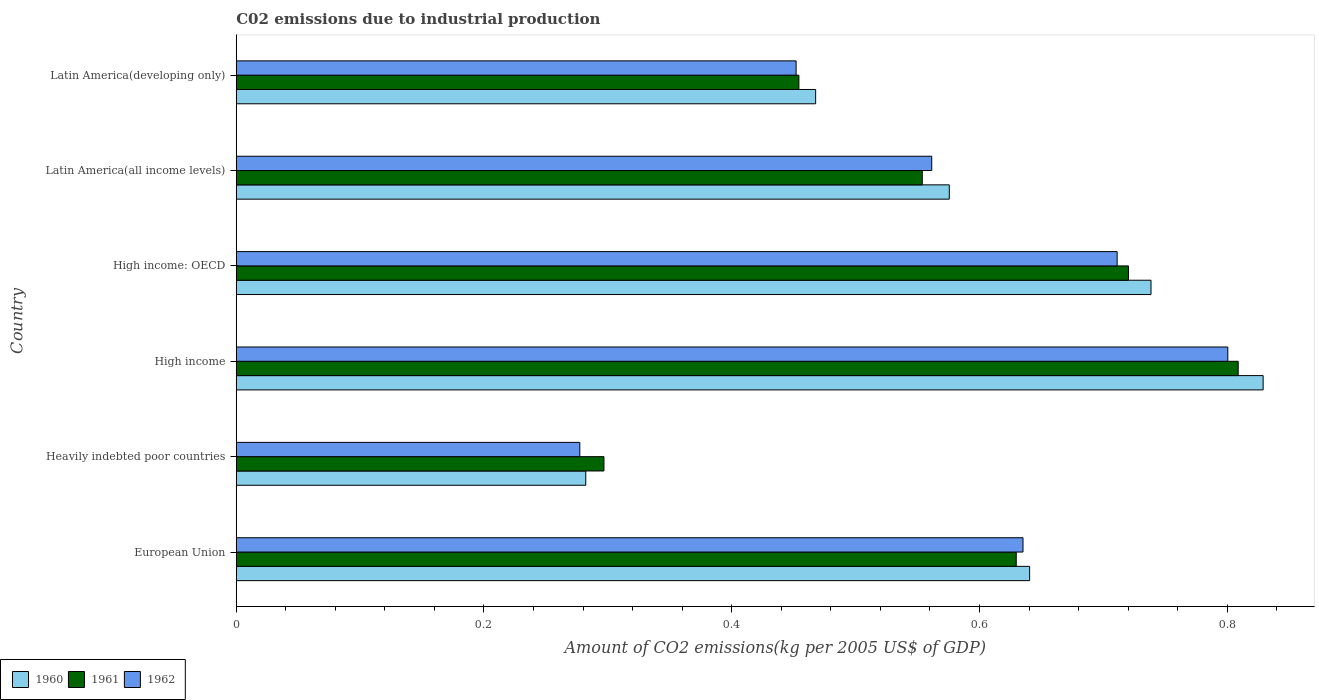How many different coloured bars are there?
Your answer should be very brief. 3. How many groups of bars are there?
Give a very brief answer. 6. Are the number of bars on each tick of the Y-axis equal?
Offer a terse response. Yes. How many bars are there on the 1st tick from the top?
Your answer should be compact. 3. How many bars are there on the 5th tick from the bottom?
Give a very brief answer. 3. What is the amount of CO2 emitted due to industrial production in 1960 in High income: OECD?
Make the answer very short. 0.74. Across all countries, what is the maximum amount of CO2 emitted due to industrial production in 1962?
Give a very brief answer. 0.8. Across all countries, what is the minimum amount of CO2 emitted due to industrial production in 1961?
Make the answer very short. 0.3. In which country was the amount of CO2 emitted due to industrial production in 1960 maximum?
Offer a terse response. High income. In which country was the amount of CO2 emitted due to industrial production in 1962 minimum?
Make the answer very short. Heavily indebted poor countries. What is the total amount of CO2 emitted due to industrial production in 1960 in the graph?
Your response must be concise. 3.53. What is the difference between the amount of CO2 emitted due to industrial production in 1961 in European Union and that in Latin America(developing only)?
Offer a terse response. 0.18. What is the difference between the amount of CO2 emitted due to industrial production in 1960 in Heavily indebted poor countries and the amount of CO2 emitted due to industrial production in 1961 in Latin America(developing only)?
Ensure brevity in your answer.  -0.17. What is the average amount of CO2 emitted due to industrial production in 1962 per country?
Your response must be concise. 0.57. What is the difference between the amount of CO2 emitted due to industrial production in 1960 and amount of CO2 emitted due to industrial production in 1961 in Latin America(all income levels)?
Provide a succinct answer. 0.02. In how many countries, is the amount of CO2 emitted due to industrial production in 1960 greater than 0.7200000000000001 kg?
Ensure brevity in your answer.  2. What is the ratio of the amount of CO2 emitted due to industrial production in 1961 in Latin America(all income levels) to that in Latin America(developing only)?
Ensure brevity in your answer.  1.22. Is the amount of CO2 emitted due to industrial production in 1962 in European Union less than that in Latin America(developing only)?
Keep it short and to the point. No. What is the difference between the highest and the second highest amount of CO2 emitted due to industrial production in 1961?
Give a very brief answer. 0.09. What is the difference between the highest and the lowest amount of CO2 emitted due to industrial production in 1961?
Offer a terse response. 0.51. Is the sum of the amount of CO2 emitted due to industrial production in 1961 in European Union and Heavily indebted poor countries greater than the maximum amount of CO2 emitted due to industrial production in 1960 across all countries?
Ensure brevity in your answer.  Yes. Is it the case that in every country, the sum of the amount of CO2 emitted due to industrial production in 1962 and amount of CO2 emitted due to industrial production in 1960 is greater than the amount of CO2 emitted due to industrial production in 1961?
Give a very brief answer. Yes. Are all the bars in the graph horizontal?
Ensure brevity in your answer.  Yes. How many countries are there in the graph?
Offer a terse response. 6. Are the values on the major ticks of X-axis written in scientific E-notation?
Your answer should be compact. No. Does the graph contain any zero values?
Provide a succinct answer. No. Does the graph contain grids?
Ensure brevity in your answer.  No. How many legend labels are there?
Offer a terse response. 3. How are the legend labels stacked?
Provide a short and direct response. Horizontal. What is the title of the graph?
Your answer should be very brief. C02 emissions due to industrial production. What is the label or title of the X-axis?
Provide a short and direct response. Amount of CO2 emissions(kg per 2005 US$ of GDP). What is the label or title of the Y-axis?
Make the answer very short. Country. What is the Amount of CO2 emissions(kg per 2005 US$ of GDP) in 1960 in European Union?
Provide a short and direct response. 0.64. What is the Amount of CO2 emissions(kg per 2005 US$ of GDP) in 1961 in European Union?
Give a very brief answer. 0.63. What is the Amount of CO2 emissions(kg per 2005 US$ of GDP) of 1962 in European Union?
Keep it short and to the point. 0.64. What is the Amount of CO2 emissions(kg per 2005 US$ of GDP) of 1960 in Heavily indebted poor countries?
Your response must be concise. 0.28. What is the Amount of CO2 emissions(kg per 2005 US$ of GDP) in 1961 in Heavily indebted poor countries?
Your answer should be compact. 0.3. What is the Amount of CO2 emissions(kg per 2005 US$ of GDP) of 1962 in Heavily indebted poor countries?
Offer a terse response. 0.28. What is the Amount of CO2 emissions(kg per 2005 US$ of GDP) of 1960 in High income?
Give a very brief answer. 0.83. What is the Amount of CO2 emissions(kg per 2005 US$ of GDP) of 1961 in High income?
Provide a short and direct response. 0.81. What is the Amount of CO2 emissions(kg per 2005 US$ of GDP) of 1962 in High income?
Ensure brevity in your answer.  0.8. What is the Amount of CO2 emissions(kg per 2005 US$ of GDP) of 1960 in High income: OECD?
Your answer should be very brief. 0.74. What is the Amount of CO2 emissions(kg per 2005 US$ of GDP) of 1961 in High income: OECD?
Offer a very short reply. 0.72. What is the Amount of CO2 emissions(kg per 2005 US$ of GDP) of 1962 in High income: OECD?
Make the answer very short. 0.71. What is the Amount of CO2 emissions(kg per 2005 US$ of GDP) in 1960 in Latin America(all income levels)?
Your answer should be compact. 0.58. What is the Amount of CO2 emissions(kg per 2005 US$ of GDP) in 1961 in Latin America(all income levels)?
Give a very brief answer. 0.55. What is the Amount of CO2 emissions(kg per 2005 US$ of GDP) in 1962 in Latin America(all income levels)?
Your answer should be compact. 0.56. What is the Amount of CO2 emissions(kg per 2005 US$ of GDP) of 1960 in Latin America(developing only)?
Ensure brevity in your answer.  0.47. What is the Amount of CO2 emissions(kg per 2005 US$ of GDP) in 1961 in Latin America(developing only)?
Ensure brevity in your answer.  0.45. What is the Amount of CO2 emissions(kg per 2005 US$ of GDP) in 1962 in Latin America(developing only)?
Give a very brief answer. 0.45. Across all countries, what is the maximum Amount of CO2 emissions(kg per 2005 US$ of GDP) of 1960?
Provide a succinct answer. 0.83. Across all countries, what is the maximum Amount of CO2 emissions(kg per 2005 US$ of GDP) of 1961?
Give a very brief answer. 0.81. Across all countries, what is the maximum Amount of CO2 emissions(kg per 2005 US$ of GDP) in 1962?
Give a very brief answer. 0.8. Across all countries, what is the minimum Amount of CO2 emissions(kg per 2005 US$ of GDP) of 1960?
Keep it short and to the point. 0.28. Across all countries, what is the minimum Amount of CO2 emissions(kg per 2005 US$ of GDP) in 1961?
Your answer should be compact. 0.3. Across all countries, what is the minimum Amount of CO2 emissions(kg per 2005 US$ of GDP) of 1962?
Offer a terse response. 0.28. What is the total Amount of CO2 emissions(kg per 2005 US$ of GDP) of 1960 in the graph?
Ensure brevity in your answer.  3.53. What is the total Amount of CO2 emissions(kg per 2005 US$ of GDP) of 1961 in the graph?
Offer a very short reply. 3.46. What is the total Amount of CO2 emissions(kg per 2005 US$ of GDP) of 1962 in the graph?
Ensure brevity in your answer.  3.44. What is the difference between the Amount of CO2 emissions(kg per 2005 US$ of GDP) of 1960 in European Union and that in Heavily indebted poor countries?
Offer a terse response. 0.36. What is the difference between the Amount of CO2 emissions(kg per 2005 US$ of GDP) of 1961 in European Union and that in Heavily indebted poor countries?
Your response must be concise. 0.33. What is the difference between the Amount of CO2 emissions(kg per 2005 US$ of GDP) of 1962 in European Union and that in Heavily indebted poor countries?
Provide a succinct answer. 0.36. What is the difference between the Amount of CO2 emissions(kg per 2005 US$ of GDP) in 1960 in European Union and that in High income?
Offer a very short reply. -0.19. What is the difference between the Amount of CO2 emissions(kg per 2005 US$ of GDP) of 1961 in European Union and that in High income?
Your answer should be compact. -0.18. What is the difference between the Amount of CO2 emissions(kg per 2005 US$ of GDP) in 1962 in European Union and that in High income?
Make the answer very short. -0.17. What is the difference between the Amount of CO2 emissions(kg per 2005 US$ of GDP) of 1960 in European Union and that in High income: OECD?
Your answer should be compact. -0.1. What is the difference between the Amount of CO2 emissions(kg per 2005 US$ of GDP) in 1961 in European Union and that in High income: OECD?
Keep it short and to the point. -0.09. What is the difference between the Amount of CO2 emissions(kg per 2005 US$ of GDP) of 1962 in European Union and that in High income: OECD?
Provide a short and direct response. -0.08. What is the difference between the Amount of CO2 emissions(kg per 2005 US$ of GDP) in 1960 in European Union and that in Latin America(all income levels)?
Provide a short and direct response. 0.06. What is the difference between the Amount of CO2 emissions(kg per 2005 US$ of GDP) of 1961 in European Union and that in Latin America(all income levels)?
Offer a terse response. 0.08. What is the difference between the Amount of CO2 emissions(kg per 2005 US$ of GDP) in 1962 in European Union and that in Latin America(all income levels)?
Offer a terse response. 0.07. What is the difference between the Amount of CO2 emissions(kg per 2005 US$ of GDP) in 1960 in European Union and that in Latin America(developing only)?
Keep it short and to the point. 0.17. What is the difference between the Amount of CO2 emissions(kg per 2005 US$ of GDP) of 1961 in European Union and that in Latin America(developing only)?
Ensure brevity in your answer.  0.18. What is the difference between the Amount of CO2 emissions(kg per 2005 US$ of GDP) in 1962 in European Union and that in Latin America(developing only)?
Your answer should be very brief. 0.18. What is the difference between the Amount of CO2 emissions(kg per 2005 US$ of GDP) of 1960 in Heavily indebted poor countries and that in High income?
Your answer should be very brief. -0.55. What is the difference between the Amount of CO2 emissions(kg per 2005 US$ of GDP) in 1961 in Heavily indebted poor countries and that in High income?
Give a very brief answer. -0.51. What is the difference between the Amount of CO2 emissions(kg per 2005 US$ of GDP) in 1962 in Heavily indebted poor countries and that in High income?
Offer a very short reply. -0.52. What is the difference between the Amount of CO2 emissions(kg per 2005 US$ of GDP) of 1960 in Heavily indebted poor countries and that in High income: OECD?
Offer a terse response. -0.46. What is the difference between the Amount of CO2 emissions(kg per 2005 US$ of GDP) in 1961 in Heavily indebted poor countries and that in High income: OECD?
Make the answer very short. -0.42. What is the difference between the Amount of CO2 emissions(kg per 2005 US$ of GDP) of 1962 in Heavily indebted poor countries and that in High income: OECD?
Your answer should be very brief. -0.43. What is the difference between the Amount of CO2 emissions(kg per 2005 US$ of GDP) in 1960 in Heavily indebted poor countries and that in Latin America(all income levels)?
Make the answer very short. -0.29. What is the difference between the Amount of CO2 emissions(kg per 2005 US$ of GDP) of 1961 in Heavily indebted poor countries and that in Latin America(all income levels)?
Provide a succinct answer. -0.26. What is the difference between the Amount of CO2 emissions(kg per 2005 US$ of GDP) in 1962 in Heavily indebted poor countries and that in Latin America(all income levels)?
Give a very brief answer. -0.28. What is the difference between the Amount of CO2 emissions(kg per 2005 US$ of GDP) in 1960 in Heavily indebted poor countries and that in Latin America(developing only)?
Your response must be concise. -0.19. What is the difference between the Amount of CO2 emissions(kg per 2005 US$ of GDP) in 1961 in Heavily indebted poor countries and that in Latin America(developing only)?
Give a very brief answer. -0.16. What is the difference between the Amount of CO2 emissions(kg per 2005 US$ of GDP) in 1962 in Heavily indebted poor countries and that in Latin America(developing only)?
Ensure brevity in your answer.  -0.17. What is the difference between the Amount of CO2 emissions(kg per 2005 US$ of GDP) in 1960 in High income and that in High income: OECD?
Your answer should be compact. 0.09. What is the difference between the Amount of CO2 emissions(kg per 2005 US$ of GDP) of 1961 in High income and that in High income: OECD?
Offer a very short reply. 0.09. What is the difference between the Amount of CO2 emissions(kg per 2005 US$ of GDP) in 1962 in High income and that in High income: OECD?
Give a very brief answer. 0.09. What is the difference between the Amount of CO2 emissions(kg per 2005 US$ of GDP) of 1960 in High income and that in Latin America(all income levels)?
Provide a succinct answer. 0.25. What is the difference between the Amount of CO2 emissions(kg per 2005 US$ of GDP) in 1961 in High income and that in Latin America(all income levels)?
Provide a short and direct response. 0.26. What is the difference between the Amount of CO2 emissions(kg per 2005 US$ of GDP) of 1962 in High income and that in Latin America(all income levels)?
Offer a very short reply. 0.24. What is the difference between the Amount of CO2 emissions(kg per 2005 US$ of GDP) of 1960 in High income and that in Latin America(developing only)?
Your answer should be compact. 0.36. What is the difference between the Amount of CO2 emissions(kg per 2005 US$ of GDP) of 1961 in High income and that in Latin America(developing only)?
Give a very brief answer. 0.35. What is the difference between the Amount of CO2 emissions(kg per 2005 US$ of GDP) in 1962 in High income and that in Latin America(developing only)?
Offer a terse response. 0.35. What is the difference between the Amount of CO2 emissions(kg per 2005 US$ of GDP) in 1960 in High income: OECD and that in Latin America(all income levels)?
Offer a very short reply. 0.16. What is the difference between the Amount of CO2 emissions(kg per 2005 US$ of GDP) of 1961 in High income: OECD and that in Latin America(all income levels)?
Offer a very short reply. 0.17. What is the difference between the Amount of CO2 emissions(kg per 2005 US$ of GDP) of 1962 in High income: OECD and that in Latin America(all income levels)?
Provide a short and direct response. 0.15. What is the difference between the Amount of CO2 emissions(kg per 2005 US$ of GDP) in 1960 in High income: OECD and that in Latin America(developing only)?
Provide a short and direct response. 0.27. What is the difference between the Amount of CO2 emissions(kg per 2005 US$ of GDP) in 1961 in High income: OECD and that in Latin America(developing only)?
Give a very brief answer. 0.27. What is the difference between the Amount of CO2 emissions(kg per 2005 US$ of GDP) in 1962 in High income: OECD and that in Latin America(developing only)?
Offer a very short reply. 0.26. What is the difference between the Amount of CO2 emissions(kg per 2005 US$ of GDP) in 1960 in Latin America(all income levels) and that in Latin America(developing only)?
Ensure brevity in your answer.  0.11. What is the difference between the Amount of CO2 emissions(kg per 2005 US$ of GDP) of 1961 in Latin America(all income levels) and that in Latin America(developing only)?
Offer a very short reply. 0.1. What is the difference between the Amount of CO2 emissions(kg per 2005 US$ of GDP) of 1962 in Latin America(all income levels) and that in Latin America(developing only)?
Provide a succinct answer. 0.11. What is the difference between the Amount of CO2 emissions(kg per 2005 US$ of GDP) in 1960 in European Union and the Amount of CO2 emissions(kg per 2005 US$ of GDP) in 1961 in Heavily indebted poor countries?
Your answer should be compact. 0.34. What is the difference between the Amount of CO2 emissions(kg per 2005 US$ of GDP) of 1960 in European Union and the Amount of CO2 emissions(kg per 2005 US$ of GDP) of 1962 in Heavily indebted poor countries?
Give a very brief answer. 0.36. What is the difference between the Amount of CO2 emissions(kg per 2005 US$ of GDP) in 1961 in European Union and the Amount of CO2 emissions(kg per 2005 US$ of GDP) in 1962 in Heavily indebted poor countries?
Ensure brevity in your answer.  0.35. What is the difference between the Amount of CO2 emissions(kg per 2005 US$ of GDP) in 1960 in European Union and the Amount of CO2 emissions(kg per 2005 US$ of GDP) in 1961 in High income?
Make the answer very short. -0.17. What is the difference between the Amount of CO2 emissions(kg per 2005 US$ of GDP) of 1960 in European Union and the Amount of CO2 emissions(kg per 2005 US$ of GDP) of 1962 in High income?
Keep it short and to the point. -0.16. What is the difference between the Amount of CO2 emissions(kg per 2005 US$ of GDP) in 1961 in European Union and the Amount of CO2 emissions(kg per 2005 US$ of GDP) in 1962 in High income?
Your response must be concise. -0.17. What is the difference between the Amount of CO2 emissions(kg per 2005 US$ of GDP) in 1960 in European Union and the Amount of CO2 emissions(kg per 2005 US$ of GDP) in 1961 in High income: OECD?
Provide a short and direct response. -0.08. What is the difference between the Amount of CO2 emissions(kg per 2005 US$ of GDP) in 1960 in European Union and the Amount of CO2 emissions(kg per 2005 US$ of GDP) in 1962 in High income: OECD?
Ensure brevity in your answer.  -0.07. What is the difference between the Amount of CO2 emissions(kg per 2005 US$ of GDP) of 1961 in European Union and the Amount of CO2 emissions(kg per 2005 US$ of GDP) of 1962 in High income: OECD?
Offer a very short reply. -0.08. What is the difference between the Amount of CO2 emissions(kg per 2005 US$ of GDP) of 1960 in European Union and the Amount of CO2 emissions(kg per 2005 US$ of GDP) of 1961 in Latin America(all income levels)?
Your answer should be very brief. 0.09. What is the difference between the Amount of CO2 emissions(kg per 2005 US$ of GDP) of 1960 in European Union and the Amount of CO2 emissions(kg per 2005 US$ of GDP) of 1962 in Latin America(all income levels)?
Provide a short and direct response. 0.08. What is the difference between the Amount of CO2 emissions(kg per 2005 US$ of GDP) in 1961 in European Union and the Amount of CO2 emissions(kg per 2005 US$ of GDP) in 1962 in Latin America(all income levels)?
Make the answer very short. 0.07. What is the difference between the Amount of CO2 emissions(kg per 2005 US$ of GDP) of 1960 in European Union and the Amount of CO2 emissions(kg per 2005 US$ of GDP) of 1961 in Latin America(developing only)?
Keep it short and to the point. 0.19. What is the difference between the Amount of CO2 emissions(kg per 2005 US$ of GDP) of 1960 in European Union and the Amount of CO2 emissions(kg per 2005 US$ of GDP) of 1962 in Latin America(developing only)?
Keep it short and to the point. 0.19. What is the difference between the Amount of CO2 emissions(kg per 2005 US$ of GDP) of 1961 in European Union and the Amount of CO2 emissions(kg per 2005 US$ of GDP) of 1962 in Latin America(developing only)?
Offer a very short reply. 0.18. What is the difference between the Amount of CO2 emissions(kg per 2005 US$ of GDP) of 1960 in Heavily indebted poor countries and the Amount of CO2 emissions(kg per 2005 US$ of GDP) of 1961 in High income?
Make the answer very short. -0.53. What is the difference between the Amount of CO2 emissions(kg per 2005 US$ of GDP) of 1960 in Heavily indebted poor countries and the Amount of CO2 emissions(kg per 2005 US$ of GDP) of 1962 in High income?
Your answer should be compact. -0.52. What is the difference between the Amount of CO2 emissions(kg per 2005 US$ of GDP) in 1961 in Heavily indebted poor countries and the Amount of CO2 emissions(kg per 2005 US$ of GDP) in 1962 in High income?
Provide a short and direct response. -0.5. What is the difference between the Amount of CO2 emissions(kg per 2005 US$ of GDP) of 1960 in Heavily indebted poor countries and the Amount of CO2 emissions(kg per 2005 US$ of GDP) of 1961 in High income: OECD?
Offer a very short reply. -0.44. What is the difference between the Amount of CO2 emissions(kg per 2005 US$ of GDP) in 1960 in Heavily indebted poor countries and the Amount of CO2 emissions(kg per 2005 US$ of GDP) in 1962 in High income: OECD?
Your answer should be compact. -0.43. What is the difference between the Amount of CO2 emissions(kg per 2005 US$ of GDP) of 1961 in Heavily indebted poor countries and the Amount of CO2 emissions(kg per 2005 US$ of GDP) of 1962 in High income: OECD?
Your answer should be very brief. -0.41. What is the difference between the Amount of CO2 emissions(kg per 2005 US$ of GDP) of 1960 in Heavily indebted poor countries and the Amount of CO2 emissions(kg per 2005 US$ of GDP) of 1961 in Latin America(all income levels)?
Your answer should be compact. -0.27. What is the difference between the Amount of CO2 emissions(kg per 2005 US$ of GDP) of 1960 in Heavily indebted poor countries and the Amount of CO2 emissions(kg per 2005 US$ of GDP) of 1962 in Latin America(all income levels)?
Provide a short and direct response. -0.28. What is the difference between the Amount of CO2 emissions(kg per 2005 US$ of GDP) in 1961 in Heavily indebted poor countries and the Amount of CO2 emissions(kg per 2005 US$ of GDP) in 1962 in Latin America(all income levels)?
Your response must be concise. -0.26. What is the difference between the Amount of CO2 emissions(kg per 2005 US$ of GDP) in 1960 in Heavily indebted poor countries and the Amount of CO2 emissions(kg per 2005 US$ of GDP) in 1961 in Latin America(developing only)?
Give a very brief answer. -0.17. What is the difference between the Amount of CO2 emissions(kg per 2005 US$ of GDP) in 1960 in Heavily indebted poor countries and the Amount of CO2 emissions(kg per 2005 US$ of GDP) in 1962 in Latin America(developing only)?
Your response must be concise. -0.17. What is the difference between the Amount of CO2 emissions(kg per 2005 US$ of GDP) of 1961 in Heavily indebted poor countries and the Amount of CO2 emissions(kg per 2005 US$ of GDP) of 1962 in Latin America(developing only)?
Your response must be concise. -0.16. What is the difference between the Amount of CO2 emissions(kg per 2005 US$ of GDP) in 1960 in High income and the Amount of CO2 emissions(kg per 2005 US$ of GDP) in 1961 in High income: OECD?
Ensure brevity in your answer.  0.11. What is the difference between the Amount of CO2 emissions(kg per 2005 US$ of GDP) in 1960 in High income and the Amount of CO2 emissions(kg per 2005 US$ of GDP) in 1962 in High income: OECD?
Your response must be concise. 0.12. What is the difference between the Amount of CO2 emissions(kg per 2005 US$ of GDP) of 1961 in High income and the Amount of CO2 emissions(kg per 2005 US$ of GDP) of 1962 in High income: OECD?
Make the answer very short. 0.1. What is the difference between the Amount of CO2 emissions(kg per 2005 US$ of GDP) in 1960 in High income and the Amount of CO2 emissions(kg per 2005 US$ of GDP) in 1961 in Latin America(all income levels)?
Your answer should be compact. 0.28. What is the difference between the Amount of CO2 emissions(kg per 2005 US$ of GDP) of 1960 in High income and the Amount of CO2 emissions(kg per 2005 US$ of GDP) of 1962 in Latin America(all income levels)?
Provide a succinct answer. 0.27. What is the difference between the Amount of CO2 emissions(kg per 2005 US$ of GDP) in 1961 in High income and the Amount of CO2 emissions(kg per 2005 US$ of GDP) in 1962 in Latin America(all income levels)?
Give a very brief answer. 0.25. What is the difference between the Amount of CO2 emissions(kg per 2005 US$ of GDP) in 1960 in High income and the Amount of CO2 emissions(kg per 2005 US$ of GDP) in 1961 in Latin America(developing only)?
Ensure brevity in your answer.  0.37. What is the difference between the Amount of CO2 emissions(kg per 2005 US$ of GDP) of 1960 in High income and the Amount of CO2 emissions(kg per 2005 US$ of GDP) of 1962 in Latin America(developing only)?
Give a very brief answer. 0.38. What is the difference between the Amount of CO2 emissions(kg per 2005 US$ of GDP) of 1961 in High income and the Amount of CO2 emissions(kg per 2005 US$ of GDP) of 1962 in Latin America(developing only)?
Offer a very short reply. 0.36. What is the difference between the Amount of CO2 emissions(kg per 2005 US$ of GDP) of 1960 in High income: OECD and the Amount of CO2 emissions(kg per 2005 US$ of GDP) of 1961 in Latin America(all income levels)?
Ensure brevity in your answer.  0.18. What is the difference between the Amount of CO2 emissions(kg per 2005 US$ of GDP) of 1960 in High income: OECD and the Amount of CO2 emissions(kg per 2005 US$ of GDP) of 1962 in Latin America(all income levels)?
Offer a very short reply. 0.18. What is the difference between the Amount of CO2 emissions(kg per 2005 US$ of GDP) in 1961 in High income: OECD and the Amount of CO2 emissions(kg per 2005 US$ of GDP) in 1962 in Latin America(all income levels)?
Make the answer very short. 0.16. What is the difference between the Amount of CO2 emissions(kg per 2005 US$ of GDP) in 1960 in High income: OECD and the Amount of CO2 emissions(kg per 2005 US$ of GDP) in 1961 in Latin America(developing only)?
Provide a succinct answer. 0.28. What is the difference between the Amount of CO2 emissions(kg per 2005 US$ of GDP) in 1960 in High income: OECD and the Amount of CO2 emissions(kg per 2005 US$ of GDP) in 1962 in Latin America(developing only)?
Give a very brief answer. 0.29. What is the difference between the Amount of CO2 emissions(kg per 2005 US$ of GDP) of 1961 in High income: OECD and the Amount of CO2 emissions(kg per 2005 US$ of GDP) of 1962 in Latin America(developing only)?
Your response must be concise. 0.27. What is the difference between the Amount of CO2 emissions(kg per 2005 US$ of GDP) in 1960 in Latin America(all income levels) and the Amount of CO2 emissions(kg per 2005 US$ of GDP) in 1961 in Latin America(developing only)?
Your answer should be very brief. 0.12. What is the difference between the Amount of CO2 emissions(kg per 2005 US$ of GDP) of 1960 in Latin America(all income levels) and the Amount of CO2 emissions(kg per 2005 US$ of GDP) of 1962 in Latin America(developing only)?
Ensure brevity in your answer.  0.12. What is the difference between the Amount of CO2 emissions(kg per 2005 US$ of GDP) of 1961 in Latin America(all income levels) and the Amount of CO2 emissions(kg per 2005 US$ of GDP) of 1962 in Latin America(developing only)?
Provide a succinct answer. 0.1. What is the average Amount of CO2 emissions(kg per 2005 US$ of GDP) in 1960 per country?
Your answer should be very brief. 0.59. What is the average Amount of CO2 emissions(kg per 2005 US$ of GDP) in 1961 per country?
Keep it short and to the point. 0.58. What is the average Amount of CO2 emissions(kg per 2005 US$ of GDP) in 1962 per country?
Give a very brief answer. 0.57. What is the difference between the Amount of CO2 emissions(kg per 2005 US$ of GDP) of 1960 and Amount of CO2 emissions(kg per 2005 US$ of GDP) of 1961 in European Union?
Ensure brevity in your answer.  0.01. What is the difference between the Amount of CO2 emissions(kg per 2005 US$ of GDP) in 1960 and Amount of CO2 emissions(kg per 2005 US$ of GDP) in 1962 in European Union?
Offer a very short reply. 0.01. What is the difference between the Amount of CO2 emissions(kg per 2005 US$ of GDP) of 1961 and Amount of CO2 emissions(kg per 2005 US$ of GDP) of 1962 in European Union?
Provide a short and direct response. -0.01. What is the difference between the Amount of CO2 emissions(kg per 2005 US$ of GDP) in 1960 and Amount of CO2 emissions(kg per 2005 US$ of GDP) in 1961 in Heavily indebted poor countries?
Ensure brevity in your answer.  -0.01. What is the difference between the Amount of CO2 emissions(kg per 2005 US$ of GDP) of 1960 and Amount of CO2 emissions(kg per 2005 US$ of GDP) of 1962 in Heavily indebted poor countries?
Your answer should be very brief. 0. What is the difference between the Amount of CO2 emissions(kg per 2005 US$ of GDP) of 1961 and Amount of CO2 emissions(kg per 2005 US$ of GDP) of 1962 in Heavily indebted poor countries?
Your answer should be very brief. 0.02. What is the difference between the Amount of CO2 emissions(kg per 2005 US$ of GDP) of 1960 and Amount of CO2 emissions(kg per 2005 US$ of GDP) of 1961 in High income?
Your answer should be compact. 0.02. What is the difference between the Amount of CO2 emissions(kg per 2005 US$ of GDP) of 1960 and Amount of CO2 emissions(kg per 2005 US$ of GDP) of 1962 in High income?
Your response must be concise. 0.03. What is the difference between the Amount of CO2 emissions(kg per 2005 US$ of GDP) in 1961 and Amount of CO2 emissions(kg per 2005 US$ of GDP) in 1962 in High income?
Offer a terse response. 0.01. What is the difference between the Amount of CO2 emissions(kg per 2005 US$ of GDP) of 1960 and Amount of CO2 emissions(kg per 2005 US$ of GDP) of 1961 in High income: OECD?
Ensure brevity in your answer.  0.02. What is the difference between the Amount of CO2 emissions(kg per 2005 US$ of GDP) in 1960 and Amount of CO2 emissions(kg per 2005 US$ of GDP) in 1962 in High income: OECD?
Give a very brief answer. 0.03. What is the difference between the Amount of CO2 emissions(kg per 2005 US$ of GDP) of 1961 and Amount of CO2 emissions(kg per 2005 US$ of GDP) of 1962 in High income: OECD?
Give a very brief answer. 0.01. What is the difference between the Amount of CO2 emissions(kg per 2005 US$ of GDP) of 1960 and Amount of CO2 emissions(kg per 2005 US$ of GDP) of 1961 in Latin America(all income levels)?
Give a very brief answer. 0.02. What is the difference between the Amount of CO2 emissions(kg per 2005 US$ of GDP) in 1960 and Amount of CO2 emissions(kg per 2005 US$ of GDP) in 1962 in Latin America(all income levels)?
Your answer should be compact. 0.01. What is the difference between the Amount of CO2 emissions(kg per 2005 US$ of GDP) of 1961 and Amount of CO2 emissions(kg per 2005 US$ of GDP) of 1962 in Latin America(all income levels)?
Your response must be concise. -0.01. What is the difference between the Amount of CO2 emissions(kg per 2005 US$ of GDP) in 1960 and Amount of CO2 emissions(kg per 2005 US$ of GDP) in 1961 in Latin America(developing only)?
Keep it short and to the point. 0.01. What is the difference between the Amount of CO2 emissions(kg per 2005 US$ of GDP) in 1960 and Amount of CO2 emissions(kg per 2005 US$ of GDP) in 1962 in Latin America(developing only)?
Make the answer very short. 0.02. What is the difference between the Amount of CO2 emissions(kg per 2005 US$ of GDP) of 1961 and Amount of CO2 emissions(kg per 2005 US$ of GDP) of 1962 in Latin America(developing only)?
Keep it short and to the point. 0. What is the ratio of the Amount of CO2 emissions(kg per 2005 US$ of GDP) of 1960 in European Union to that in Heavily indebted poor countries?
Offer a terse response. 2.27. What is the ratio of the Amount of CO2 emissions(kg per 2005 US$ of GDP) in 1961 in European Union to that in Heavily indebted poor countries?
Your response must be concise. 2.12. What is the ratio of the Amount of CO2 emissions(kg per 2005 US$ of GDP) of 1962 in European Union to that in Heavily indebted poor countries?
Offer a very short reply. 2.29. What is the ratio of the Amount of CO2 emissions(kg per 2005 US$ of GDP) of 1960 in European Union to that in High income?
Your answer should be compact. 0.77. What is the ratio of the Amount of CO2 emissions(kg per 2005 US$ of GDP) in 1961 in European Union to that in High income?
Keep it short and to the point. 0.78. What is the ratio of the Amount of CO2 emissions(kg per 2005 US$ of GDP) of 1962 in European Union to that in High income?
Offer a terse response. 0.79. What is the ratio of the Amount of CO2 emissions(kg per 2005 US$ of GDP) of 1960 in European Union to that in High income: OECD?
Provide a succinct answer. 0.87. What is the ratio of the Amount of CO2 emissions(kg per 2005 US$ of GDP) in 1961 in European Union to that in High income: OECD?
Your answer should be very brief. 0.87. What is the ratio of the Amount of CO2 emissions(kg per 2005 US$ of GDP) in 1962 in European Union to that in High income: OECD?
Make the answer very short. 0.89. What is the ratio of the Amount of CO2 emissions(kg per 2005 US$ of GDP) in 1960 in European Union to that in Latin America(all income levels)?
Your answer should be very brief. 1.11. What is the ratio of the Amount of CO2 emissions(kg per 2005 US$ of GDP) in 1961 in European Union to that in Latin America(all income levels)?
Offer a very short reply. 1.14. What is the ratio of the Amount of CO2 emissions(kg per 2005 US$ of GDP) in 1962 in European Union to that in Latin America(all income levels)?
Your answer should be very brief. 1.13. What is the ratio of the Amount of CO2 emissions(kg per 2005 US$ of GDP) of 1960 in European Union to that in Latin America(developing only)?
Ensure brevity in your answer.  1.37. What is the ratio of the Amount of CO2 emissions(kg per 2005 US$ of GDP) of 1961 in European Union to that in Latin America(developing only)?
Provide a succinct answer. 1.39. What is the ratio of the Amount of CO2 emissions(kg per 2005 US$ of GDP) in 1962 in European Union to that in Latin America(developing only)?
Your answer should be compact. 1.41. What is the ratio of the Amount of CO2 emissions(kg per 2005 US$ of GDP) of 1960 in Heavily indebted poor countries to that in High income?
Offer a very short reply. 0.34. What is the ratio of the Amount of CO2 emissions(kg per 2005 US$ of GDP) in 1961 in Heavily indebted poor countries to that in High income?
Ensure brevity in your answer.  0.37. What is the ratio of the Amount of CO2 emissions(kg per 2005 US$ of GDP) in 1962 in Heavily indebted poor countries to that in High income?
Provide a short and direct response. 0.35. What is the ratio of the Amount of CO2 emissions(kg per 2005 US$ of GDP) of 1960 in Heavily indebted poor countries to that in High income: OECD?
Your response must be concise. 0.38. What is the ratio of the Amount of CO2 emissions(kg per 2005 US$ of GDP) in 1961 in Heavily indebted poor countries to that in High income: OECD?
Keep it short and to the point. 0.41. What is the ratio of the Amount of CO2 emissions(kg per 2005 US$ of GDP) in 1962 in Heavily indebted poor countries to that in High income: OECD?
Ensure brevity in your answer.  0.39. What is the ratio of the Amount of CO2 emissions(kg per 2005 US$ of GDP) in 1960 in Heavily indebted poor countries to that in Latin America(all income levels)?
Your response must be concise. 0.49. What is the ratio of the Amount of CO2 emissions(kg per 2005 US$ of GDP) in 1961 in Heavily indebted poor countries to that in Latin America(all income levels)?
Provide a short and direct response. 0.54. What is the ratio of the Amount of CO2 emissions(kg per 2005 US$ of GDP) of 1962 in Heavily indebted poor countries to that in Latin America(all income levels)?
Ensure brevity in your answer.  0.49. What is the ratio of the Amount of CO2 emissions(kg per 2005 US$ of GDP) in 1960 in Heavily indebted poor countries to that in Latin America(developing only)?
Your answer should be very brief. 0.6. What is the ratio of the Amount of CO2 emissions(kg per 2005 US$ of GDP) in 1961 in Heavily indebted poor countries to that in Latin America(developing only)?
Ensure brevity in your answer.  0.65. What is the ratio of the Amount of CO2 emissions(kg per 2005 US$ of GDP) of 1962 in Heavily indebted poor countries to that in Latin America(developing only)?
Make the answer very short. 0.61. What is the ratio of the Amount of CO2 emissions(kg per 2005 US$ of GDP) in 1960 in High income to that in High income: OECD?
Keep it short and to the point. 1.12. What is the ratio of the Amount of CO2 emissions(kg per 2005 US$ of GDP) of 1961 in High income to that in High income: OECD?
Your answer should be very brief. 1.12. What is the ratio of the Amount of CO2 emissions(kg per 2005 US$ of GDP) in 1962 in High income to that in High income: OECD?
Offer a terse response. 1.13. What is the ratio of the Amount of CO2 emissions(kg per 2005 US$ of GDP) of 1960 in High income to that in Latin America(all income levels)?
Your response must be concise. 1.44. What is the ratio of the Amount of CO2 emissions(kg per 2005 US$ of GDP) in 1961 in High income to that in Latin America(all income levels)?
Provide a short and direct response. 1.46. What is the ratio of the Amount of CO2 emissions(kg per 2005 US$ of GDP) of 1962 in High income to that in Latin America(all income levels)?
Your answer should be very brief. 1.43. What is the ratio of the Amount of CO2 emissions(kg per 2005 US$ of GDP) in 1960 in High income to that in Latin America(developing only)?
Your answer should be compact. 1.77. What is the ratio of the Amount of CO2 emissions(kg per 2005 US$ of GDP) in 1961 in High income to that in Latin America(developing only)?
Keep it short and to the point. 1.78. What is the ratio of the Amount of CO2 emissions(kg per 2005 US$ of GDP) of 1962 in High income to that in Latin America(developing only)?
Keep it short and to the point. 1.77. What is the ratio of the Amount of CO2 emissions(kg per 2005 US$ of GDP) in 1960 in High income: OECD to that in Latin America(all income levels)?
Offer a terse response. 1.28. What is the ratio of the Amount of CO2 emissions(kg per 2005 US$ of GDP) of 1961 in High income: OECD to that in Latin America(all income levels)?
Offer a terse response. 1.3. What is the ratio of the Amount of CO2 emissions(kg per 2005 US$ of GDP) of 1962 in High income: OECD to that in Latin America(all income levels)?
Keep it short and to the point. 1.27. What is the ratio of the Amount of CO2 emissions(kg per 2005 US$ of GDP) of 1960 in High income: OECD to that in Latin America(developing only)?
Offer a terse response. 1.58. What is the ratio of the Amount of CO2 emissions(kg per 2005 US$ of GDP) in 1961 in High income: OECD to that in Latin America(developing only)?
Your answer should be compact. 1.59. What is the ratio of the Amount of CO2 emissions(kg per 2005 US$ of GDP) in 1962 in High income: OECD to that in Latin America(developing only)?
Provide a short and direct response. 1.57. What is the ratio of the Amount of CO2 emissions(kg per 2005 US$ of GDP) in 1960 in Latin America(all income levels) to that in Latin America(developing only)?
Provide a short and direct response. 1.23. What is the ratio of the Amount of CO2 emissions(kg per 2005 US$ of GDP) of 1961 in Latin America(all income levels) to that in Latin America(developing only)?
Offer a very short reply. 1.22. What is the ratio of the Amount of CO2 emissions(kg per 2005 US$ of GDP) of 1962 in Latin America(all income levels) to that in Latin America(developing only)?
Your answer should be very brief. 1.24. What is the difference between the highest and the second highest Amount of CO2 emissions(kg per 2005 US$ of GDP) of 1960?
Keep it short and to the point. 0.09. What is the difference between the highest and the second highest Amount of CO2 emissions(kg per 2005 US$ of GDP) in 1961?
Provide a succinct answer. 0.09. What is the difference between the highest and the second highest Amount of CO2 emissions(kg per 2005 US$ of GDP) of 1962?
Provide a short and direct response. 0.09. What is the difference between the highest and the lowest Amount of CO2 emissions(kg per 2005 US$ of GDP) in 1960?
Offer a terse response. 0.55. What is the difference between the highest and the lowest Amount of CO2 emissions(kg per 2005 US$ of GDP) of 1961?
Keep it short and to the point. 0.51. What is the difference between the highest and the lowest Amount of CO2 emissions(kg per 2005 US$ of GDP) of 1962?
Make the answer very short. 0.52. 